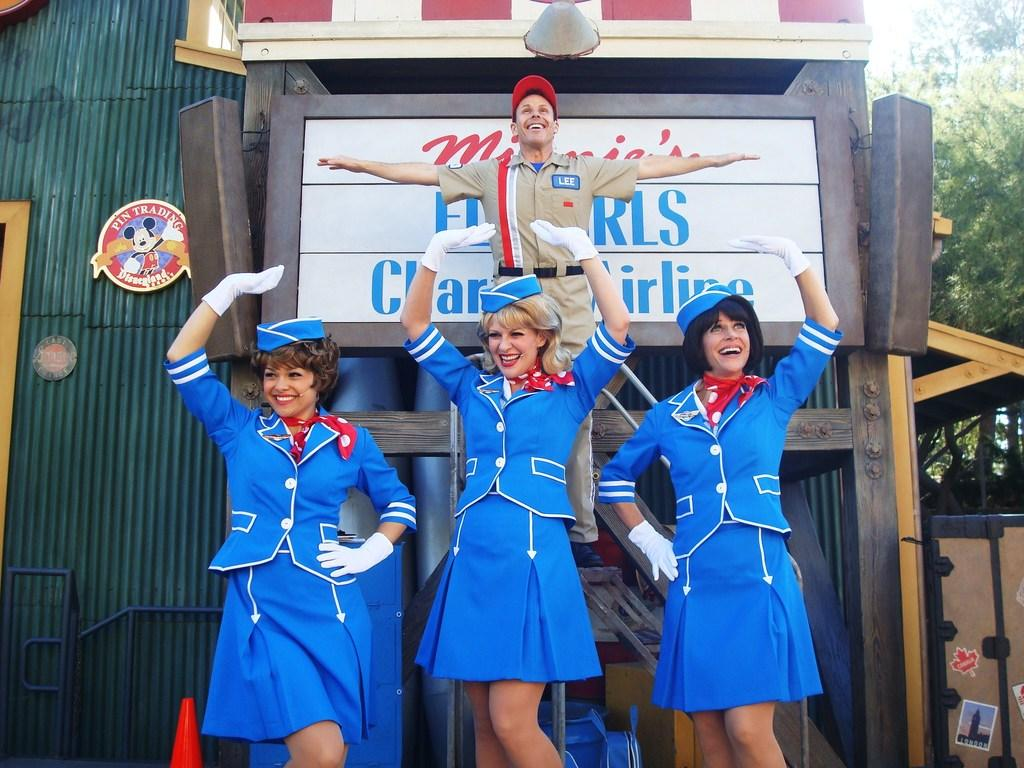Provide a one-sentence caption for the provided image. A man wearing a name tag that says Lee is lifted up by women dressed as flight attendants. 